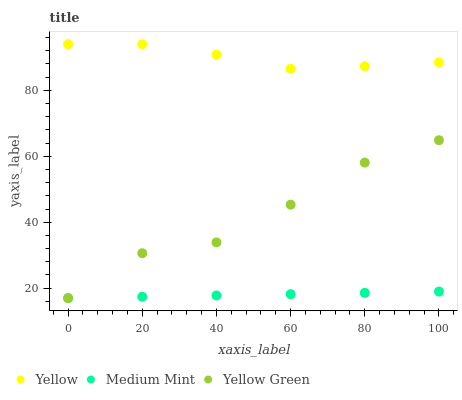Does Medium Mint have the minimum area under the curve?
Answer yes or no. Yes. Does Yellow have the maximum area under the curve?
Answer yes or no. Yes. Does Yellow Green have the minimum area under the curve?
Answer yes or no. No. Does Yellow Green have the maximum area under the curve?
Answer yes or no. No. Is Medium Mint the smoothest?
Answer yes or no. Yes. Is Yellow Green the roughest?
Answer yes or no. Yes. Is Yellow the smoothest?
Answer yes or no. No. Is Yellow the roughest?
Answer yes or no. No. Does Medium Mint have the lowest value?
Answer yes or no. Yes. Does Yellow have the lowest value?
Answer yes or no. No. Does Yellow have the highest value?
Answer yes or no. Yes. Does Yellow Green have the highest value?
Answer yes or no. No. Is Yellow Green less than Yellow?
Answer yes or no. Yes. Is Yellow greater than Medium Mint?
Answer yes or no. Yes. Does Medium Mint intersect Yellow Green?
Answer yes or no. Yes. Is Medium Mint less than Yellow Green?
Answer yes or no. No. Is Medium Mint greater than Yellow Green?
Answer yes or no. No. Does Yellow Green intersect Yellow?
Answer yes or no. No. 